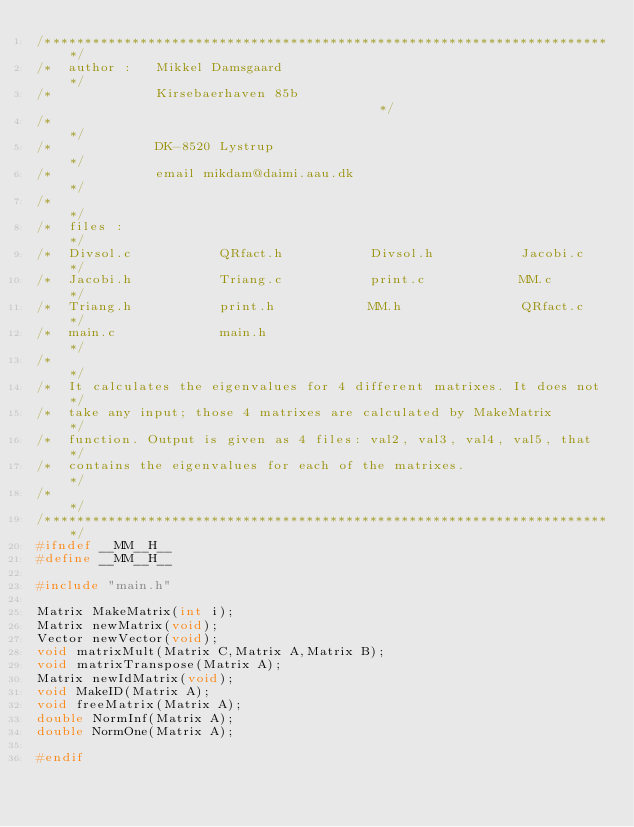Convert code to text. <code><loc_0><loc_0><loc_500><loc_500><_C_>/************************************************************************/
/*  author :   Mikkel Damsgaard                                         */
/*             Kirsebaerhaven 85b                                        */
/*                                                                      */
/*             DK-8520 Lystrup                                          */
/*             email mikdam@daimi.aau.dk                                */
/*                                                                      */
/*  files :                                                             */
/*  Divsol.c           QRfact.h           Divsol.h           Jacobi.c   */     
/*  Jacobi.h           Triang.c           print.c            MM.c       */   
/*  Triang.h           print.h            MM.h               QRfact.c   */   
/*  main.c             main.h                                           */
/*                                                                      */
/*  It calculates the eigenvalues for 4 different matrixes. It does not */
/*  take any input; those 4 matrixes are calculated by MakeMatrix       */
/*  function. Output is given as 4 files: val2, val3, val4, val5, that  */
/*  contains the eigenvalues for each of the matrixes.                  */
/*                                                                      */
/************************************************************************/
#ifndef __MM__H__
#define __MM__H__

#include "main.h"

Matrix MakeMatrix(int i);
Matrix newMatrix(void);
Vector newVector(void);
void matrixMult(Matrix C,Matrix A,Matrix B);
void matrixTranspose(Matrix A);
Matrix newIdMatrix(void);
void MakeID(Matrix A);
void freeMatrix(Matrix A);
double NormInf(Matrix A);
double NormOne(Matrix A);

#endif


</code> 